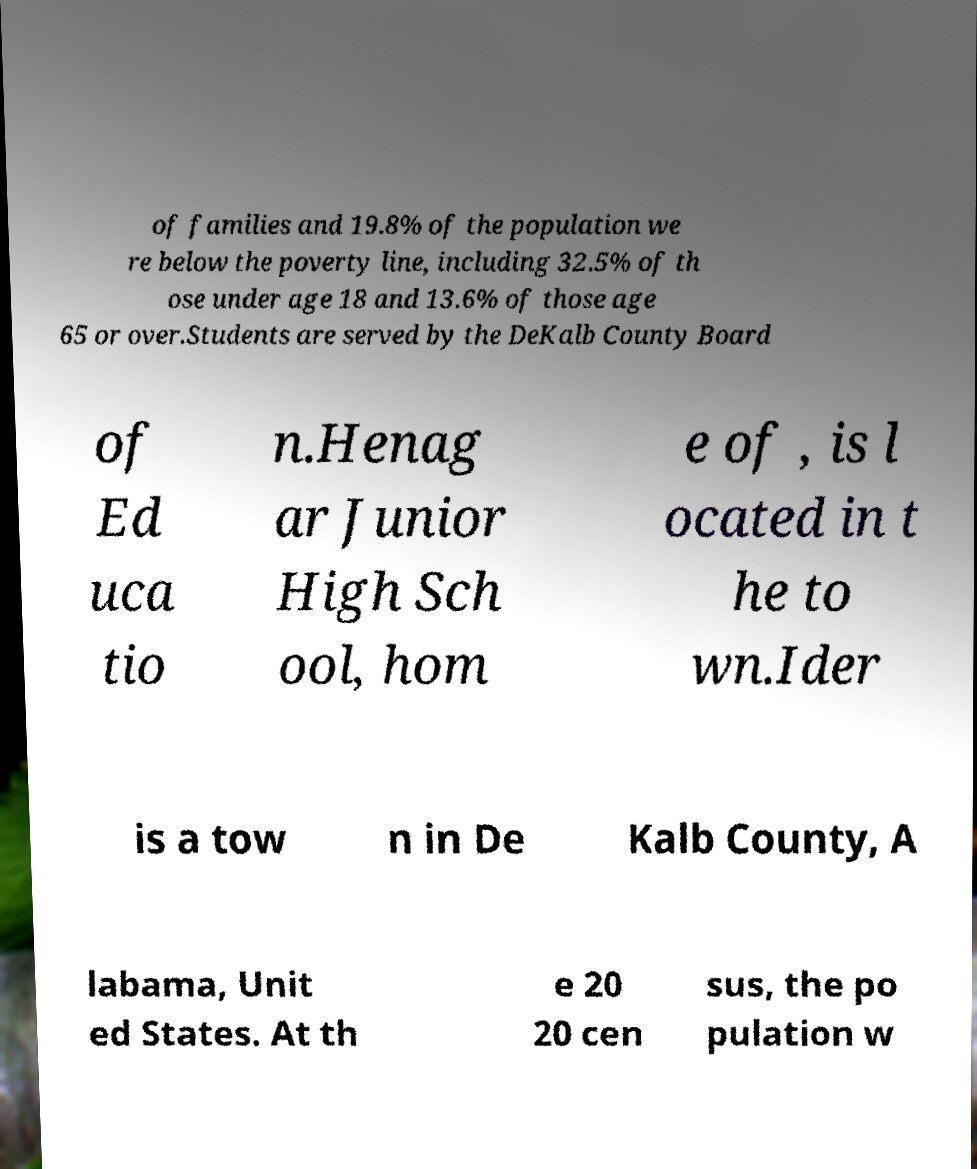What messages or text are displayed in this image? I need them in a readable, typed format. of families and 19.8% of the population we re below the poverty line, including 32.5% of th ose under age 18 and 13.6% of those age 65 or over.Students are served by the DeKalb County Board of Ed uca tio n.Henag ar Junior High Sch ool, hom e of , is l ocated in t he to wn.Ider is a tow n in De Kalb County, A labama, Unit ed States. At th e 20 20 cen sus, the po pulation w 